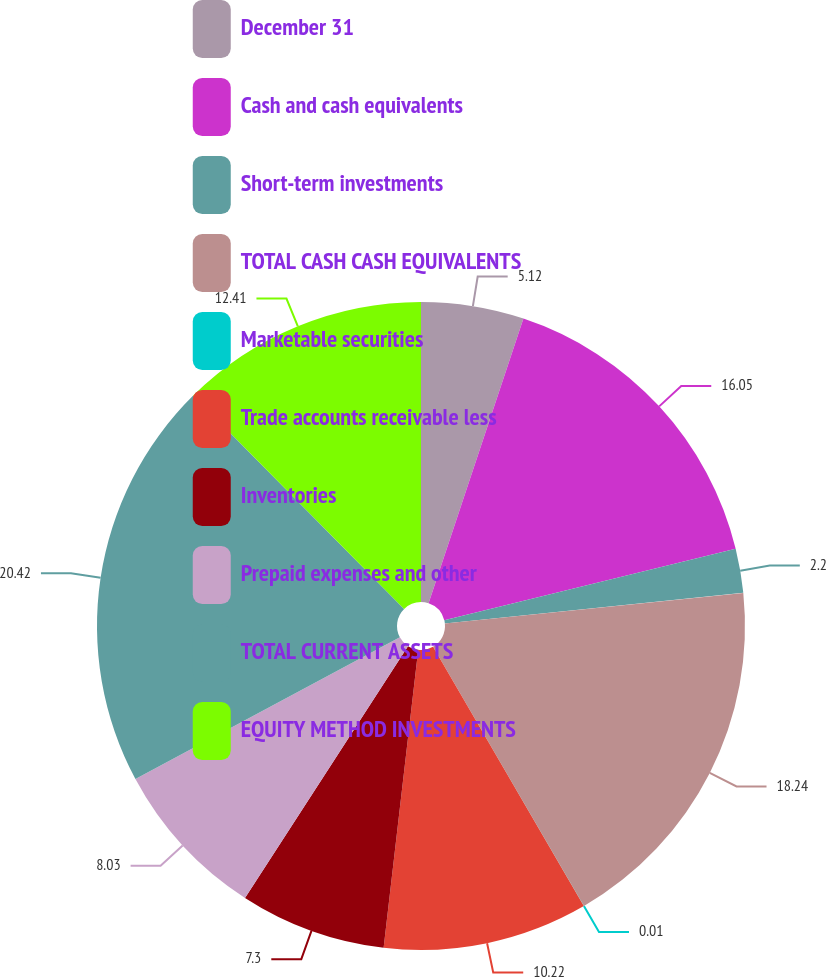<chart> <loc_0><loc_0><loc_500><loc_500><pie_chart><fcel>December 31<fcel>Cash and cash equivalents<fcel>Short-term investments<fcel>TOTAL CASH CASH EQUIVALENTS<fcel>Marketable securities<fcel>Trade accounts receivable less<fcel>Inventories<fcel>Prepaid expenses and other<fcel>TOTAL CURRENT ASSETS<fcel>EQUITY METHOD INVESTMENTS<nl><fcel>5.12%<fcel>16.05%<fcel>2.2%<fcel>18.24%<fcel>0.01%<fcel>10.22%<fcel>7.3%<fcel>8.03%<fcel>20.42%<fcel>12.41%<nl></chart> 